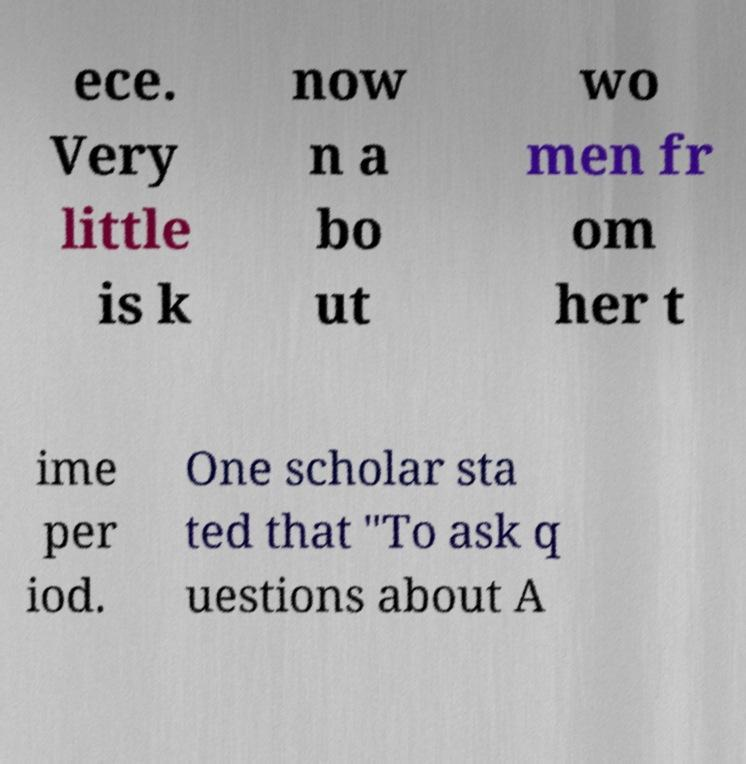For documentation purposes, I need the text within this image transcribed. Could you provide that? ece. Very little is k now n a bo ut wo men fr om her t ime per iod. One scholar sta ted that "To ask q uestions about A 